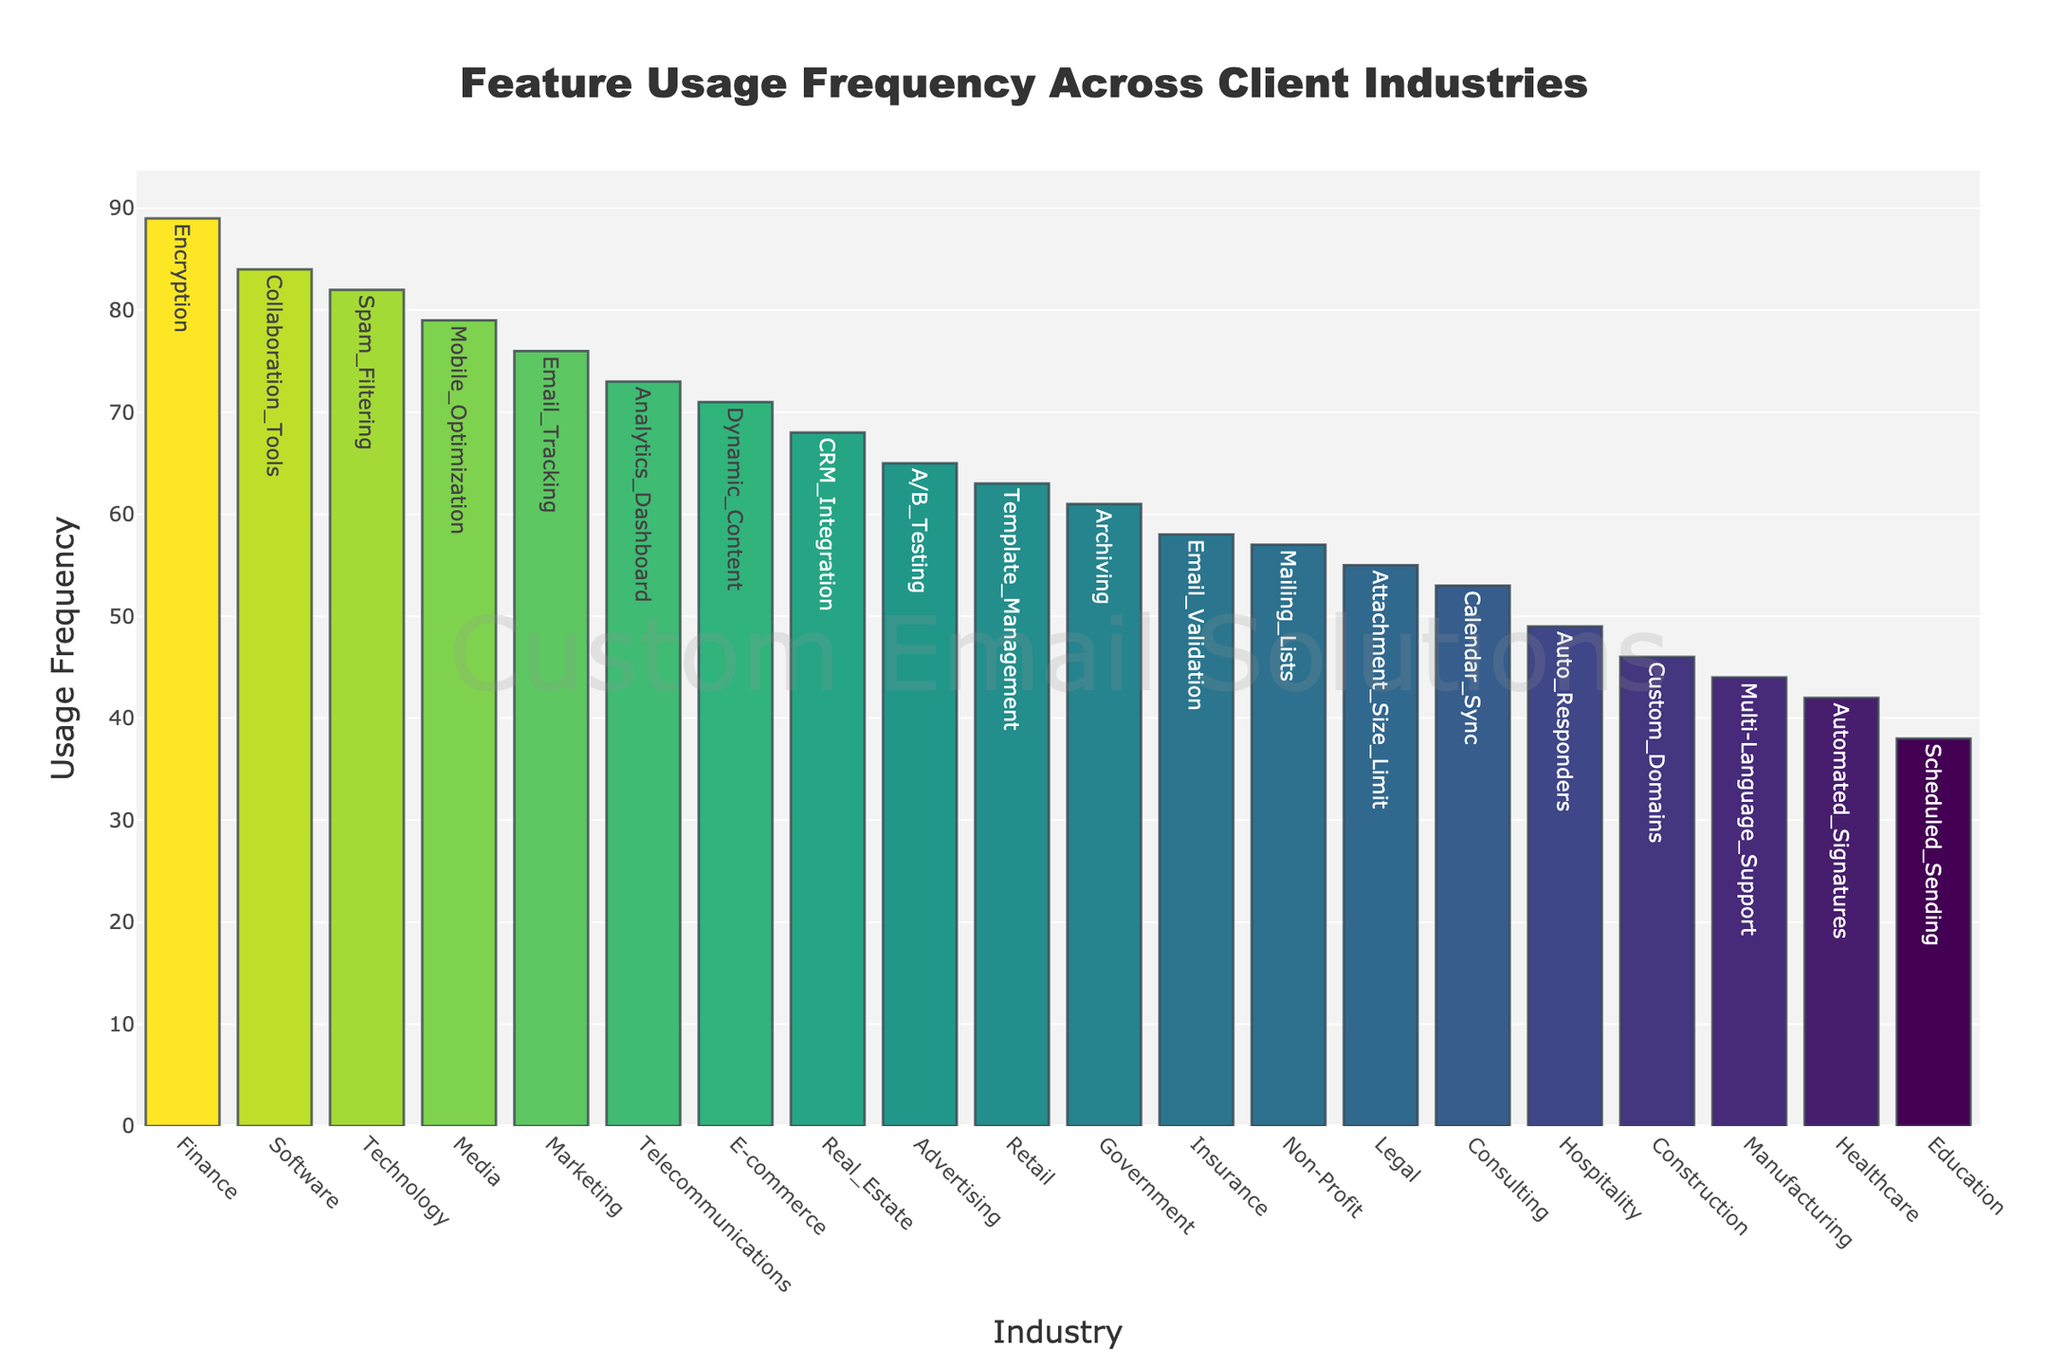What is the title of the plot? The title is located at the top center of the plot in a larger font size compared to other text elements. Title texts are commonly used to describe the subject or purpose of a visual representation.
Answer: Feature Usage Frequency Across Client Industries Which industry has the highest feature usage frequency? To find the industry with the highest feature usage frequency, look for the tallest bar in the bar plot. The y-axis shows usage frequencies, and the highest bar indicates the top frequency.
Answer: Finance What feature has the lowest usage frequency, and in which industry is it used? Locate the shortest bar in the plot, which represents the lowest usage frequency. The corresponding text next to this bar tells us the associated feature and industry.
Answer: Scheduled Sending, Education What is the average usage frequency across all industries? Sum up all the usage frequencies for each industry and divide by the number of industries (which is given by the number of bars). The formula is: average = (sum of all frequencies) / (number of industries).
Answer: (42 + 89 + 63 + 76 + 55 + 38 + 71 + 49 + 82 + 57 + 68 + 53 + 44 + 79 + 61 + 73 + 65 + 84 + 58 + 46) / 20 = 63.65, so approximately 63.65 Which industries have a feature usage frequency greater than 70? Identify all bars with a height exceeding the 70 mark on the y-axis. The associated text next to each of these bars shows the corresponding industry.
Answer: Finance, Marketing, E-commerce, Technology, Media, Telecommunications, Software Compare the usage frequency of Email Tracking (Marketing) and Attachment Size Limit (Legal). Which one is higher? Find the bars labeled Marketing (Email Tracking) and Legal (Attachment Size Limit). Compare their heights to know which one is higher.
Answer: Marketing (Email Tracking) What is the total feature usage frequency for industries with names starting with 'M'? Sum the usage frequencies of all industries whose names begin with the letter 'M'. In this case, Manufacturing (Multi-Language Support) and Marketing (Email Tracking) are considered.
Answer: 44 (Manufacturing) + 76 (Marketing) = 120 How many industries have a usage frequency of more than 50 but less than 80? Count all bars with heights between the 50 and 80 marks on the y-axis.
Answer: 9 What is the difference in usage frequency between Automated Signatures (Healthcare) and Auto Responders (Hospitality)? Subtract the usage frequency of Auto Responders (Hospitality) from Automated Signatures (Healthcare).
Answer: 42 - 49 = -7 Which industry uses the feature 'Encryption', and what is its usage frequency? Find the name 'Encryption' in the text labels next to the bars to locate the industry and note the height of the corresponding bar.
Answer: Finance, 89 